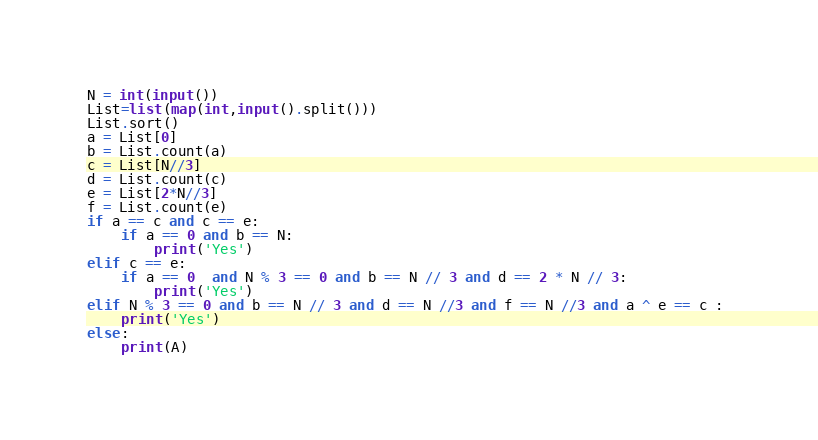Convert code to text. <code><loc_0><loc_0><loc_500><loc_500><_Python_>N = int(input())
List=list(map(int,input().split()))
List.sort()
a = List[0]
b = List.count(a)
c = List[N//3]
d = List.count(c)
e = List[2*N//3]
f = List.count(e)
if a == c and c == e:
    if a == 0 and b == N:
        print('Yes')
elif c == e:
    if a == 0  and N % 3 == 0 and b == N // 3 and d == 2 * N // 3:
        print('Yes')
elif N % 3 == 0 and b == N // 3 and d == N //3 and f == N //3 and a ^ e == c : 
    print('Yes')
else:
    print(A)
</code> 